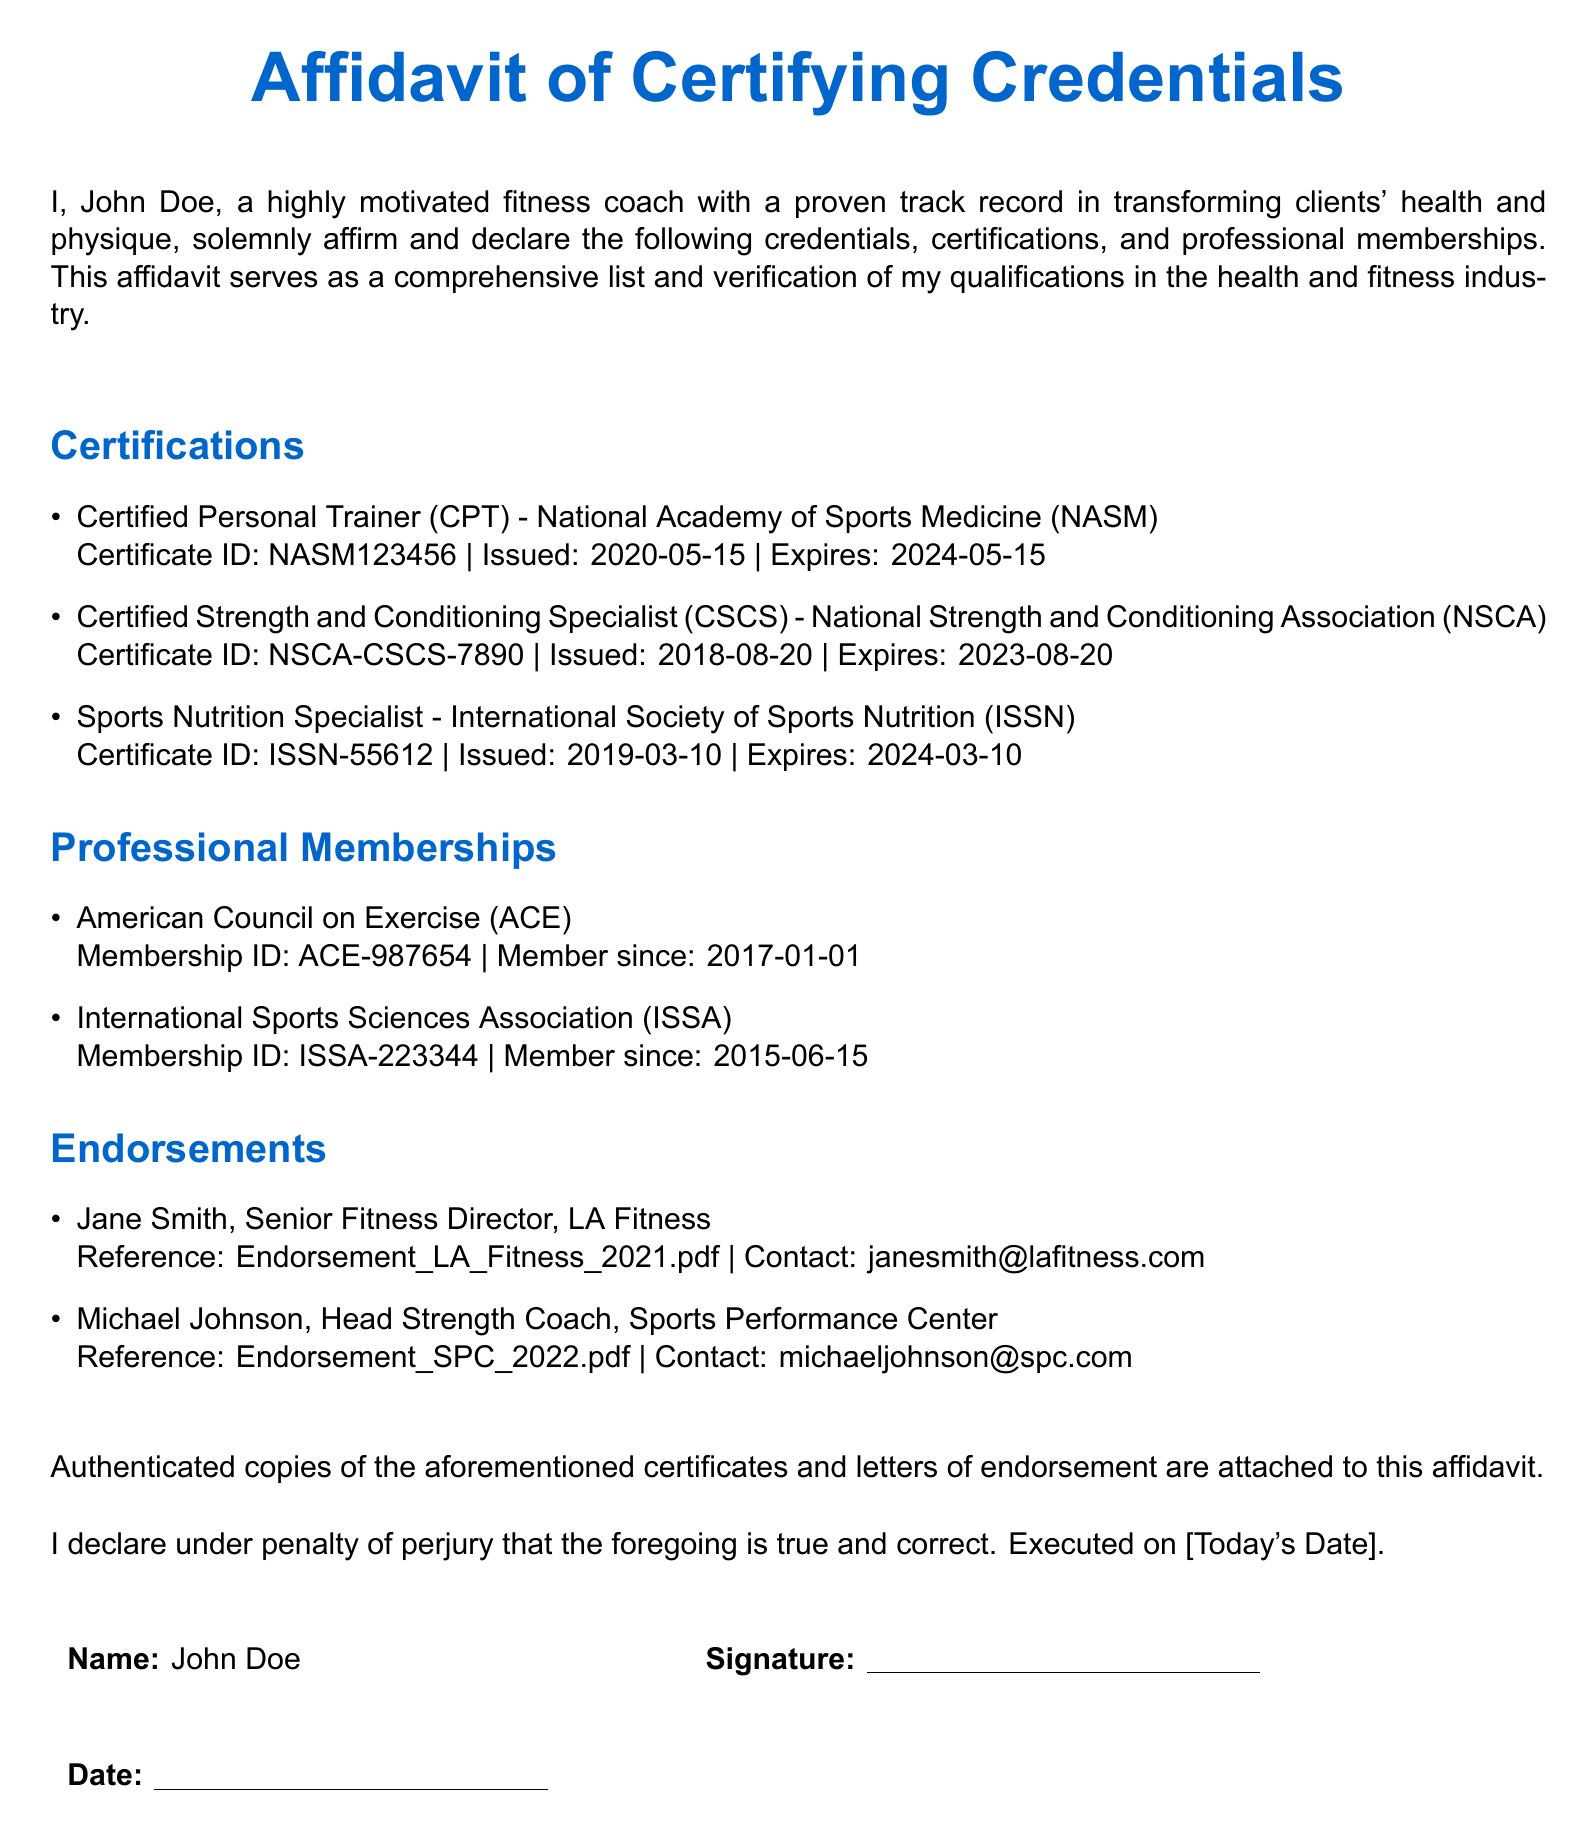What is the name of the fitness coach? The document states the fitness coach's name as John Doe.
Answer: John Doe What is the expiration date of the Certified Personal Trainer certification? The document lists the expiration date for the Certified Personal Trainer certification issued by NASM.
Answer: 2024-05-15 Which organization issued the Sports Nutrition Specialist certification? The document indicates that the Sports Nutrition Specialist certification is issued by the International Society of Sports Nutrition.
Answer: International Society of Sports Nutrition How long has the fitness coach been a member of the American Council on Exercise? The document states the membership date for the American Council on Exercise, which indicates the duration of membership.
Answer: Since 2017-01-01 Who endorsed the fitness coach at LA Fitness? The document lists endorsements and specifies who provided the endorsement at LA Fitness.
Answer: Jane Smith How many certifications are listed in the affidavit? The document specifies the number of certifications the fitness coach holds.
Answer: Three What is the Certificate ID for the Certified Strength and Conditioning Specialist? The document includes specific information for each certification, including their Certificate IDs.
Answer: NSCA-CSCS-7890 What is the contact email for the Head Strength Coach endorsement? The document specifies the contact information for the endorsement from the Head Strength Coach.
Answer: michaeljohnson@spc.com What is the status of the affidavit, according to the statement at the bottom? The document includes the statement regarding the validity of the information presented.
Answer: True and correct 